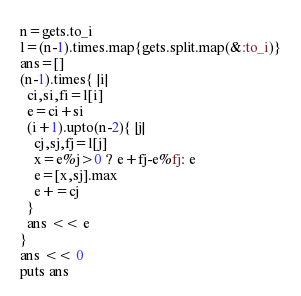Convert code to text. <code><loc_0><loc_0><loc_500><loc_500><_Ruby_>n=gets.to_i
l=(n-1).times.map{gets.split.map(&:to_i)}
ans=[]
(n-1).times{ |i|
  ci,si,fi=l[i]
  e=ci+si
  (i+1).upto(n-2){ |j|
    cj,sj,fj=l[j]
    x=e%j>0 ? e+fj-e%fj: e
    e=[x,sj].max
    e+=cj
  }
  ans << e
}
ans << 0
puts ans
</code> 